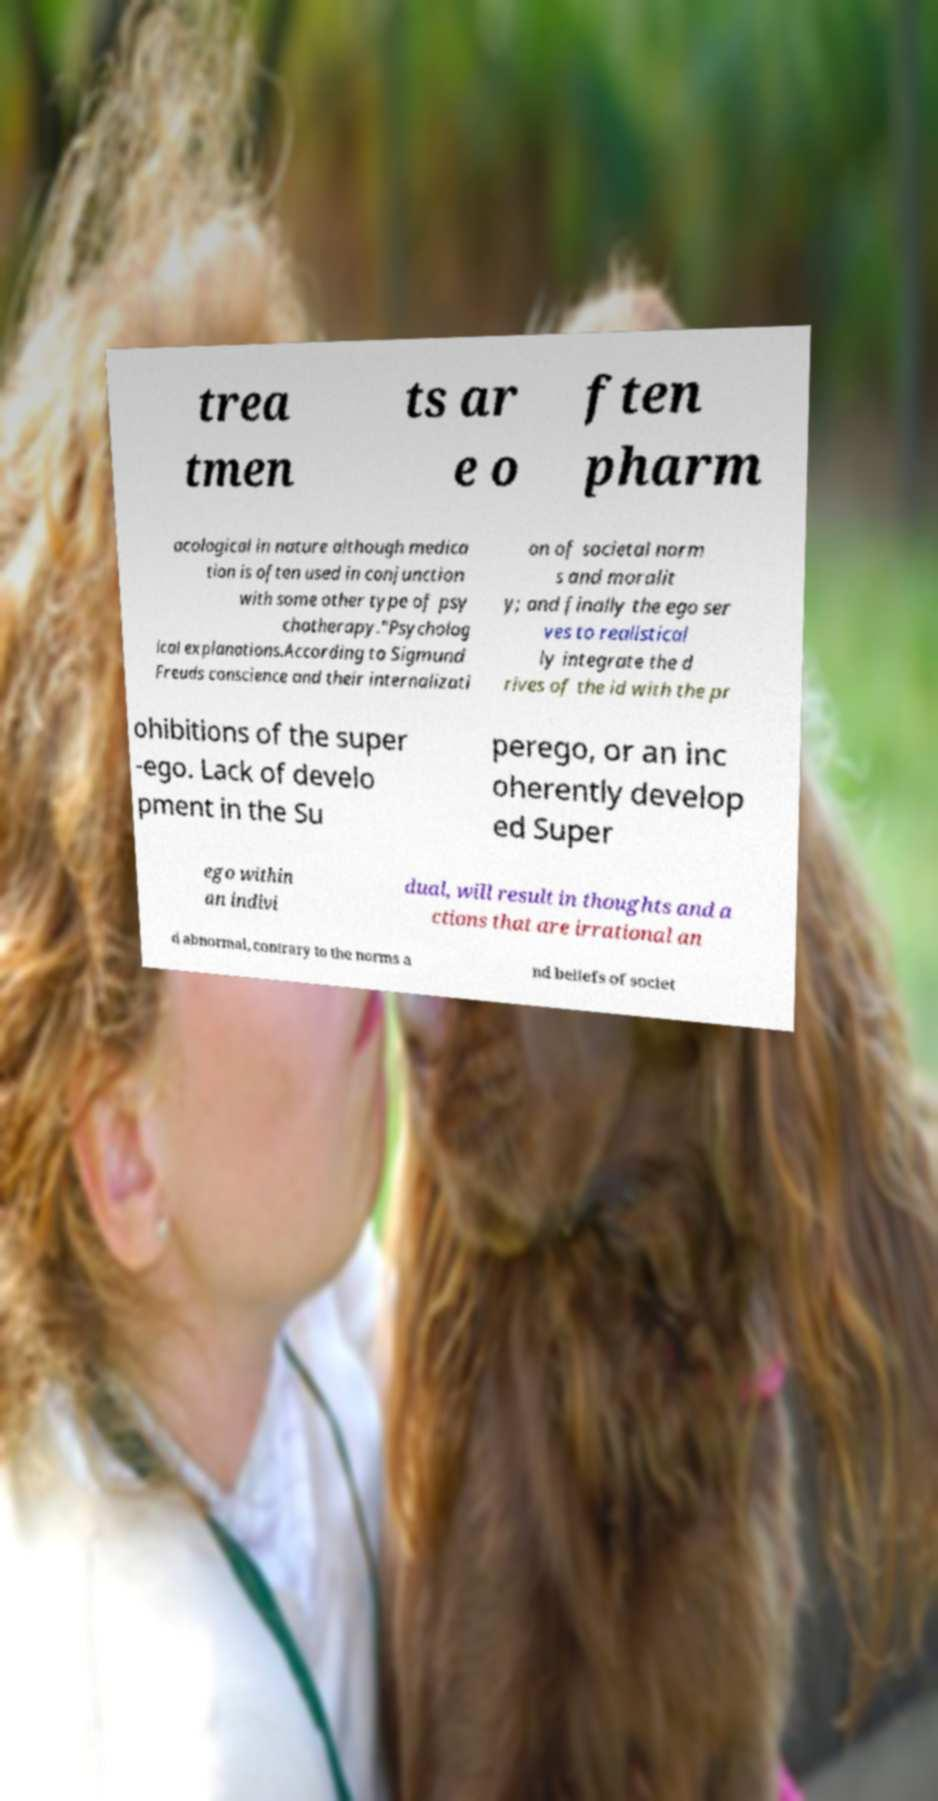For documentation purposes, I need the text within this image transcribed. Could you provide that? trea tmen ts ar e o ften pharm acological in nature although medica tion is often used in conjunction with some other type of psy chotherapy."Psycholog ical explanations.According to Sigmund Freuds conscience and their internalizati on of societal norm s and moralit y; and finally the ego ser ves to realistical ly integrate the d rives of the id with the pr ohibitions of the super -ego. Lack of develo pment in the Su perego, or an inc oherently develop ed Super ego within an indivi dual, will result in thoughts and a ctions that are irrational an d abnormal, contrary to the norms a nd beliefs of societ 